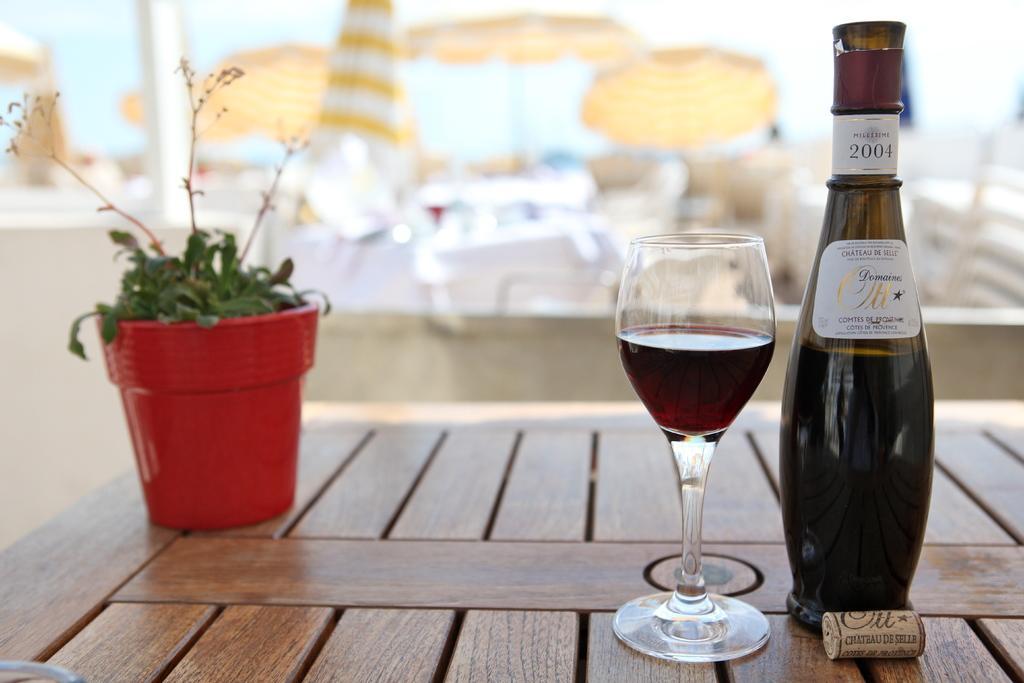Could you give a brief overview of what you see in this image? This image consists of a table. On the table there is a plant, there is a bottle and glass. 